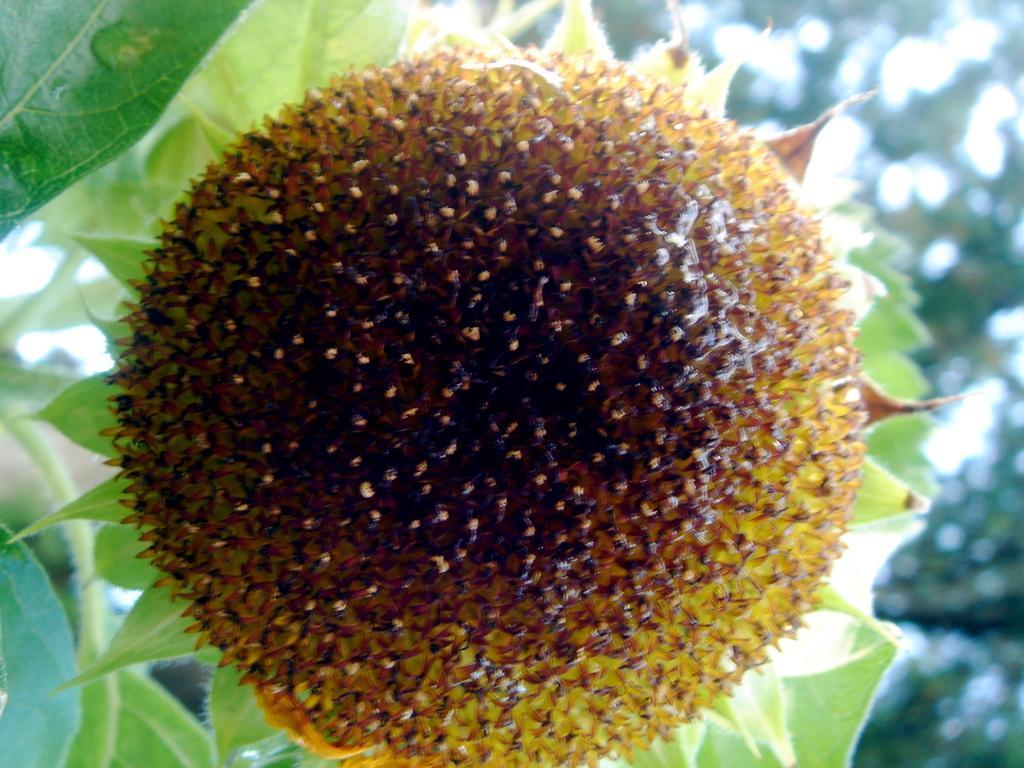Could you give a brief overview of what you see in this image? Here in this picture we can see pollen grains of a flower, which is present on a plant over there. 